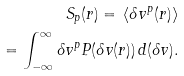Convert formula to latex. <formula><loc_0><loc_0><loc_500><loc_500>S _ { p } ( r ) = \, \langle \delta v ^ { p } ( r ) \rangle \\ = \int _ { - \infty } ^ { \infty } \delta v ^ { p } P ( \delta v ( r ) ) \, d ( \delta v ) .</formula> 